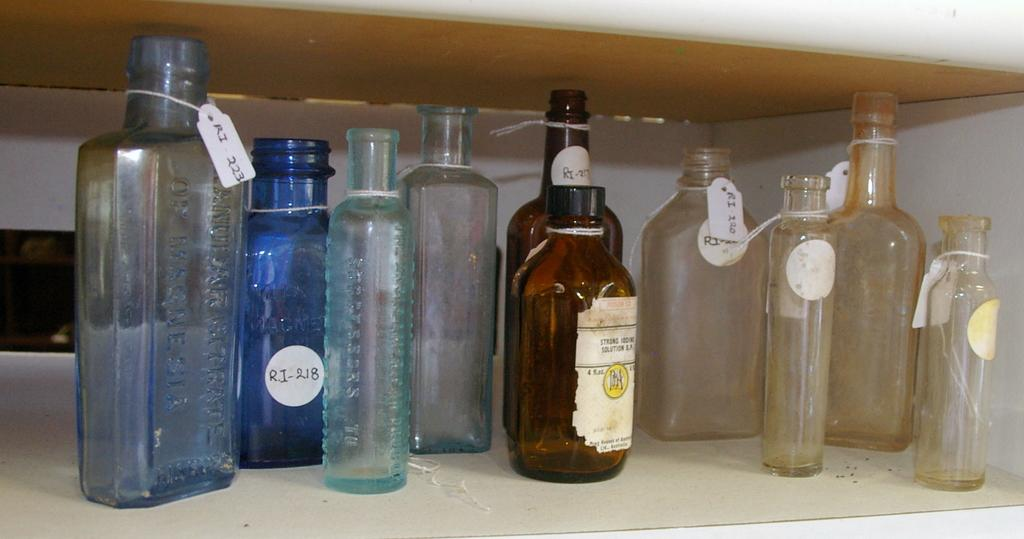What is the primary subject of the image? The primary subject of the image is a lot of bottles. Can you describe the bottles in the image? Unfortunately, the facts provided do not give specific details about the bottles, such as their color, shape, or contents. Are there any other objects or elements in the image besides the bottles? The facts provided do not mention any other objects or elements in the image. What is the size of the tramp in the image? There is no tramp present in the image; it only features a lot of bottles. 